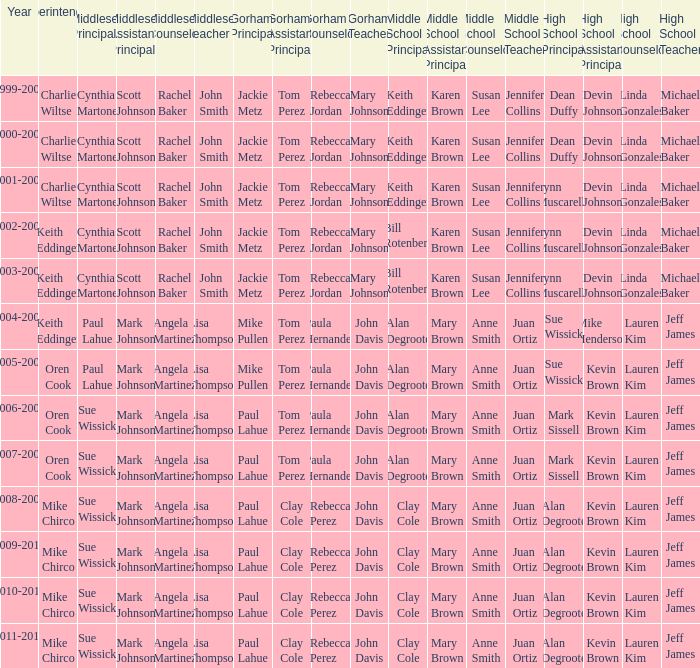Who was the gorham principal in 2010-2011? Paul Lahue. Could you parse the entire table? {'header': ['Year', 'Superintendent', 'Middlesex Principal', 'Middlesex Assistant Principal', 'Middlesex Counselor', 'Middlesex Teacher', 'Gorham Principal', 'Gorham Assistant Principal', 'Gorham Counselor', 'Gorham Teacher', 'Middle School Principal', 'Middle School Assistant Principal', 'Middle School Counselor', 'Middle School Teacher', 'High School Principal', 'High School Assistant Principal', 'High School Counselor', 'High School Teacher'], 'rows': [['1999-2000', 'Charlie Wiltse', 'Cynthia Martone', 'Scott Johnson', 'Rachel Baker', 'John Smith', 'Jackie Metz', 'Tom Perez', 'Rebecca Jordan', 'Mary Johnson', 'Keith Eddinger', 'Karen Brown', 'Susan Lee', 'Jennifer Collins', 'Dean Duffy', 'Devin Johnson', 'Linda Gonzales', 'Michael Baker'], ['2000-2001', 'Charlie Wiltse', 'Cynthia Martone', 'Scott Johnson', 'Rachel Baker', 'John Smith', 'Jackie Metz', 'Tom Perez', 'Rebecca Jordan', 'Mary Johnson', 'Keith Eddinger', 'Karen Brown', 'Susan Lee', 'Jennifer Collins', 'Dean Duffy', 'Devin Johnson', 'Linda Gonzales', 'Michael Baker'], ['2001-2002', 'Charlie Wiltse', 'Cynthia Martone', 'Scott Johnson', 'Rachel Baker', 'John Smith', 'Jackie Metz', 'Tom Perez', 'Rebecca Jordan', 'Mary Johnson', 'Keith Eddinger', 'Karen Brown', 'Susan Lee', 'Jennifer Collins', 'Lynn Muscarella', 'Devin Johnson', 'Linda Gonzales', 'Michael Baker'], ['2002-2003', 'Keith Eddinger', 'Cynthia Martone', 'Scott Johnson', 'Rachel Baker', 'John Smith', 'Jackie Metz', 'Tom Perez', 'Rebecca Jordan', 'Mary Johnson', 'Bill Rotenberg', 'Karen Brown', 'Susan Lee', 'Jennifer Collins', 'Lynn Muscarella', 'Devin Johnson', 'Linda Gonzales', 'Michael Baker'], ['2003-2004', 'Keith Eddinger', 'Cynthia Martone', 'Scott Johnson', 'Rachel Baker', 'John Smith', 'Jackie Metz', 'Tom Perez', 'Rebecca Jordan', 'Mary Johnson', 'Bill Rotenberg', 'Karen Brown', 'Susan Lee', 'Jennifer Collins', 'Lynn Muscarella', 'Devin Johnson', 'Linda Gonzales', 'Michael Baker'], ['2004-2005', 'Keith Eddinger', 'Paul Lahue', 'Mark Johnson', 'Angela Martinez', 'Lisa Thompson', 'Mike Pullen', 'Tom Perez', 'Paula Hernandez', 'John Davis', 'Alan Degroote', 'Mary Brown', 'Anne Smith', 'Juan Ortiz', 'Sue Wissick', 'Mike Henderson', 'Lauren Kim', 'Jeff James'], ['2005-2006', 'Oren Cook', 'Paul Lahue', 'Mark Johnson', 'Angela Martinez', 'Lisa Thompson', 'Mike Pullen', 'Tom Perez', 'Paula Hernandez', 'John Davis', 'Alan Degroote', 'Mary Brown', 'Anne Smith', 'Juan Ortiz', 'Sue Wissick', 'Kevin Brown', 'Lauren Kim', 'Jeff James'], ['2006-2007', 'Oren Cook', 'Sue Wissick', 'Mark Johnson', 'Angela Martinez', 'Lisa Thompson', 'Paul Lahue', 'Tom Perez', 'Paula Hernandez', 'John Davis', 'Alan Degroote', 'Mary Brown', 'Anne Smith', 'Juan Ortiz', 'Mark Sissell', 'Kevin Brown', 'Lauren Kim', 'Jeff James'], ['2007-2008', 'Oren Cook', 'Sue Wissick', 'Mark Johnson', 'Angela Martinez', 'Lisa Thompson', 'Paul Lahue', 'Tom Perez', 'Paula Hernandez', 'John Davis', 'Alan Degroote', 'Mary Brown', 'Anne Smith', 'Juan Ortiz', 'Mark Sissell', 'Kevin Brown', 'Lauren Kim', 'Jeff James'], ['2008-2009', 'Mike Chirco', 'Sue Wissick', 'Mark Johnson', 'Angela Martinez', 'Lisa Thompson', 'Paul Lahue', 'Clay Cole', 'Rebecca Perez', 'John Davis', 'Clay Cole', 'Mary Brown', 'Anne Smith', 'Juan Ortiz', 'Alan Degroote', 'Kevin Brown', 'Lauren Kim', 'Jeff James'], ['2009-2010', 'Mike Chirco', 'Sue Wissick', 'Mark Johnson', 'Angela Martinez', 'Lisa Thompson', 'Paul Lahue', 'Clay Cole', 'Rebecca Perez', 'John Davis', 'Clay Cole', 'Mary Brown', 'Anne Smith', 'Juan Ortiz', 'Alan Degroote', 'Kevin Brown', 'Lauren Kim', 'Jeff James'], ['2010-2011', 'Mike Chirco', 'Sue Wissick', 'Mark Johnson', 'Angela Martinez', 'Lisa Thompson', 'Paul Lahue', 'Clay Cole', 'Rebecca Perez', 'John Davis', 'Clay Cole', 'Mary Brown', 'Anne Smith', 'Juan Ortiz', 'Alan Degroote', 'Kevin Brown', 'Lauren Kim', 'Jeff James'], ['2011-2012', 'Mike Chirco', 'Sue Wissick', 'Mark Johnson', 'Angela Martinez', 'Lisa Thompson', 'Paul Lahue', 'Clay Cole', 'Rebecca Perez', 'John Davis', 'Clay Cole', 'Mary Brown', 'Anne Smith', 'Juan Ortiz', 'Alan Degroote', 'Kevin Brown', 'Lauren Kim', 'Jeff James']]} 